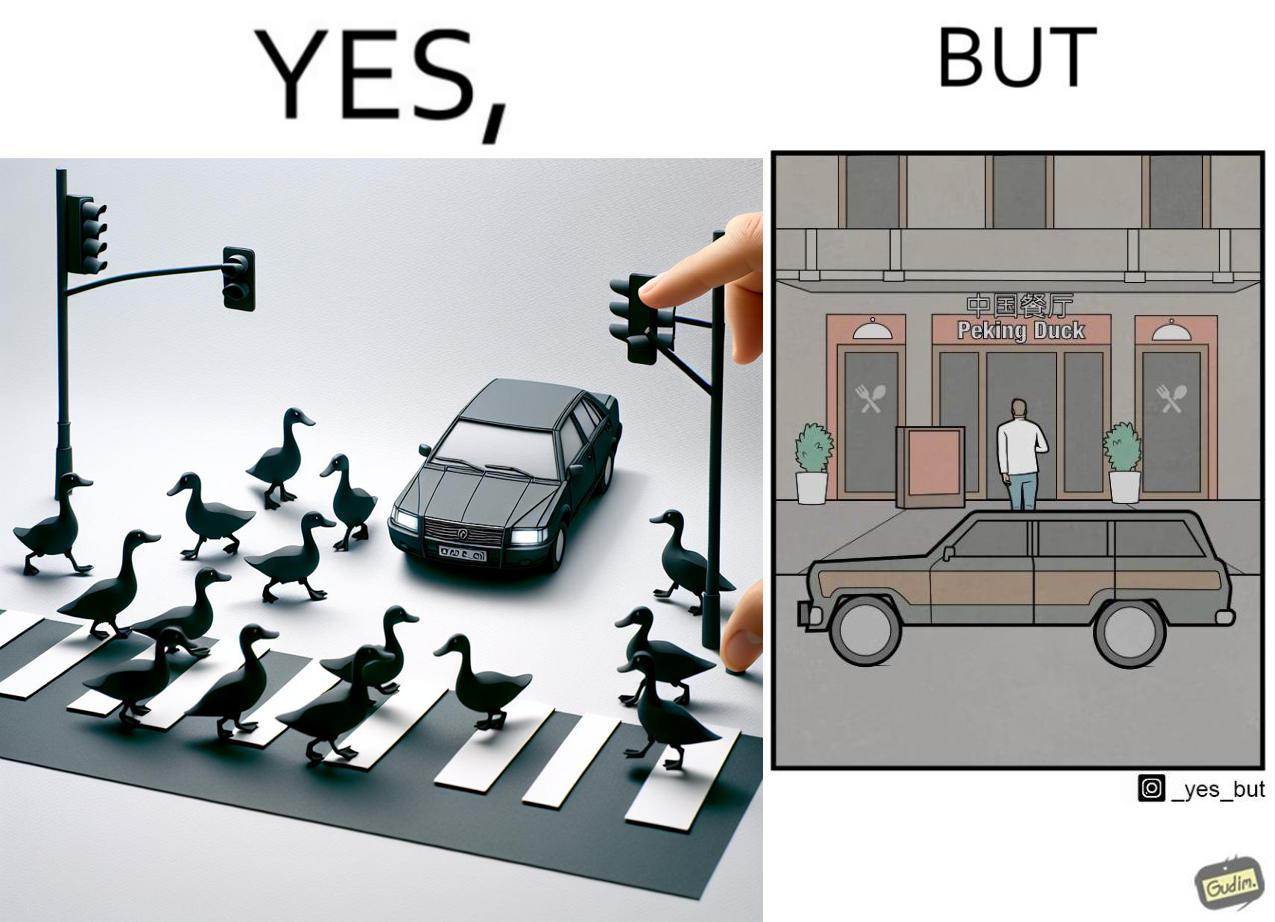Describe what you see in the left and right parts of this image. In the left part of the image: It is a car stopping to give way to queue of ducks crossing the road and allow them to cross safely In the right part of the image: It is a man parking his car and entering a peking duck shop 